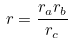Convert formula to latex. <formula><loc_0><loc_0><loc_500><loc_500>r = \frac { r _ { a } r _ { b } } { r _ { c } }</formula> 